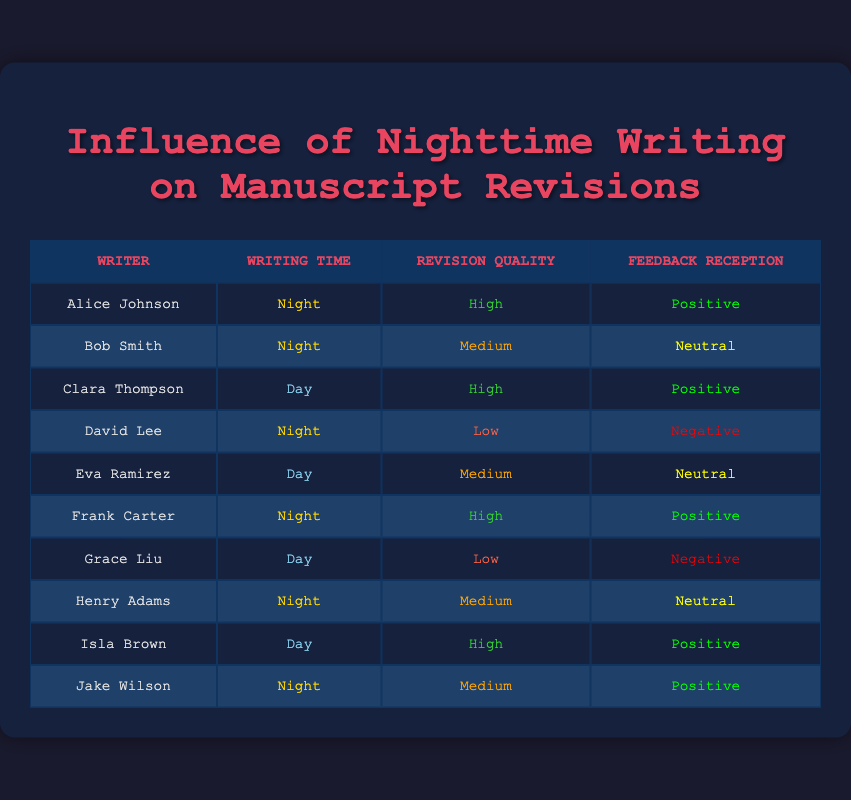What is the total number of writers who wrote at night? The table lists 10 writers, and by counting the rows where the "Writing Time" is "Night", we identify 5 writers: Alice Johnson, Bob Smith, David Lee, Frank Carter, and Jake Wilson.
Answer: 5 Which writer received negative feedback after writing at night? By examining the "Feedback Reception" column for writers who wrote at "Night", we find that only David Lee received "Negative" feedback.
Answer: David Lee How many writers received positive feedback in total? Positive feedback appears in the "Feedback Reception" column for Alice Johnson, Clara Thompson, Frank Carter, Isla Brown, and Jake Wilson. Counting these, we find there are 5 writers who received positive feedback.
Answer: 5 What is the average revision quality for those who wrote at night? The revision quality ratings for writers who wrote at night are: High, Medium, Low, High, Medium. Assigning numerical values: High=3, Medium=2, Low=1, we get (3 + 2 + 1 + 3 + 2) = 11. Dividing by the number of writers (5) gives an average of 11/5 = 2.2.
Answer: 2.2 Is there a correlation between nighttime writing and receiving neutral feedback? There are two writers with neutral feedback during nighttime (Bob Smith and Henry Adams). This indicates a potential correlation, but since they also fall under medium quality revisions, further analysis is needed for a definitive conclusion. However, based on the data provided, we see an occurrence of neutral feedback linked to nighttime writing.
Answer: Yes 